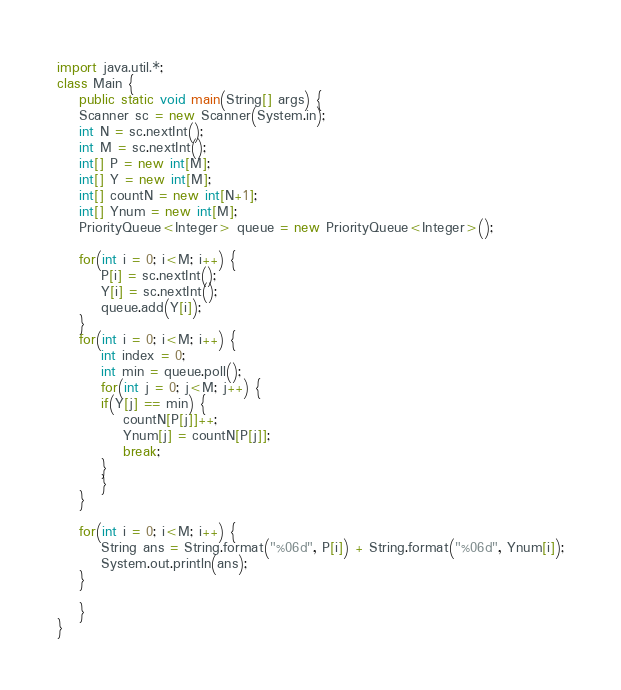Convert code to text. <code><loc_0><loc_0><loc_500><loc_500><_Java_>import java.util.*;
class Main {
    public static void main(String[] args) {
	Scanner sc = new Scanner(System.in);
	int N = sc.nextInt();
	int M = sc.nextInt();
	int[] P = new int[M];
	int[] Y = new int[M];
	int[] countN = new int[N+1];
	int[] Ynum = new int[M];
	PriorityQueue<Integer> queue = new PriorityQueue<Integer>();

	for(int i = 0; i<M; i++) {
	    P[i] = sc.nextInt();
	    Y[i] = sc.nextInt();
	    queue.add(Y[i]);
	}
	for(int i = 0; i<M; i++) {
	    int index = 0;
	    int min = queue.poll();
	    for(int j = 0; j<M; j++) {
		if(Y[j] == min) {
		    countN[P[j]]++;
		    Ynum[j] = countN[P[j]];
		    break;
		}
	    }
	}

	for(int i = 0; i<M; i++) {
	    String ans = String.format("%06d", P[i]) + String.format("%06d", Ynum[i]);
	    System.out.println(ans);
	}

    }
}</code> 